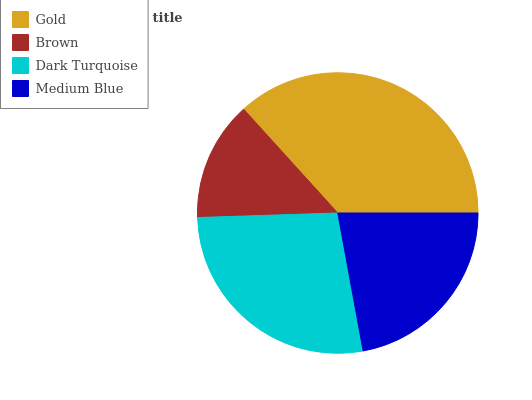Is Brown the minimum?
Answer yes or no. Yes. Is Gold the maximum?
Answer yes or no. Yes. Is Dark Turquoise the minimum?
Answer yes or no. No. Is Dark Turquoise the maximum?
Answer yes or no. No. Is Dark Turquoise greater than Brown?
Answer yes or no. Yes. Is Brown less than Dark Turquoise?
Answer yes or no. Yes. Is Brown greater than Dark Turquoise?
Answer yes or no. No. Is Dark Turquoise less than Brown?
Answer yes or no. No. Is Dark Turquoise the high median?
Answer yes or no. Yes. Is Medium Blue the low median?
Answer yes or no. Yes. Is Brown the high median?
Answer yes or no. No. Is Brown the low median?
Answer yes or no. No. 